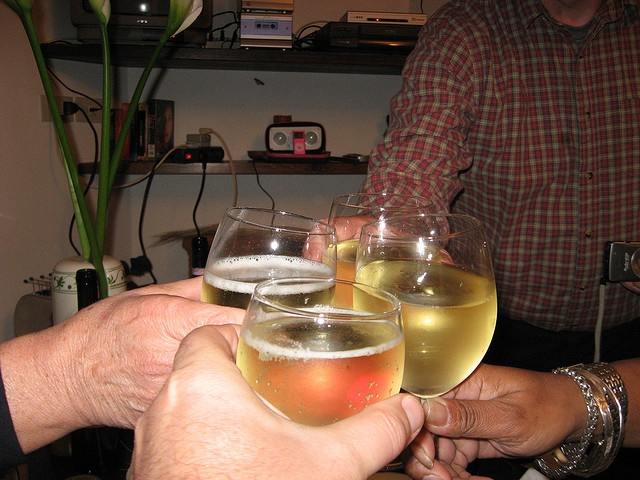Describe the objects in this image and their specific colors. I can see people in black, maroon, and gray tones, people in black, tan, and salmon tones, people in black, brown, and maroon tones, wine glass in black, orange, tan, salmon, and lightgray tones, and wine glass in black, olive, maroon, and gray tones in this image. 